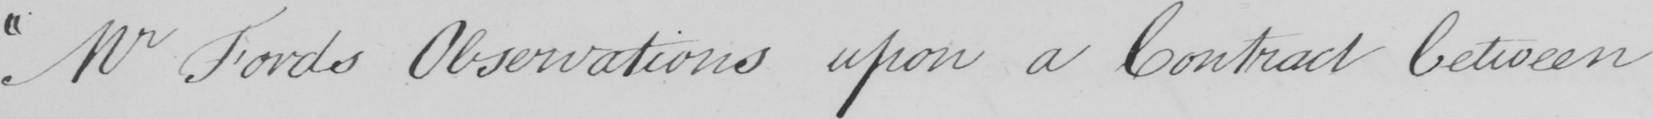What does this handwritten line say? " Mr Fords Observations upon a Contract between 